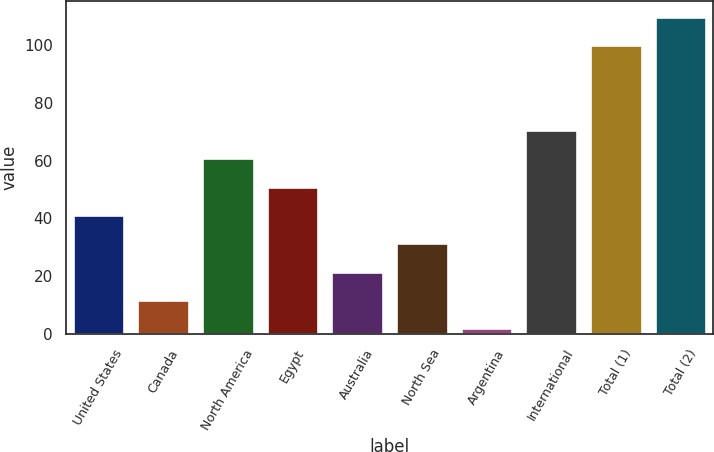Convert chart to OTSL. <chart><loc_0><loc_0><loc_500><loc_500><bar_chart><fcel>United States<fcel>Canada<fcel>North America<fcel>Egypt<fcel>Australia<fcel>North Sea<fcel>Argentina<fcel>International<fcel>Total (1)<fcel>Total (2)<nl><fcel>41.2<fcel>11.8<fcel>60.8<fcel>51<fcel>21.6<fcel>31.4<fcel>2<fcel>70.6<fcel>100<fcel>109.8<nl></chart> 